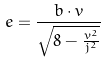Convert formula to latex. <formula><loc_0><loc_0><loc_500><loc_500>e = \frac { b \cdot v } { \sqrt { 8 - \frac { v ^ { 2 } } { j ^ { 2 } } } }</formula> 